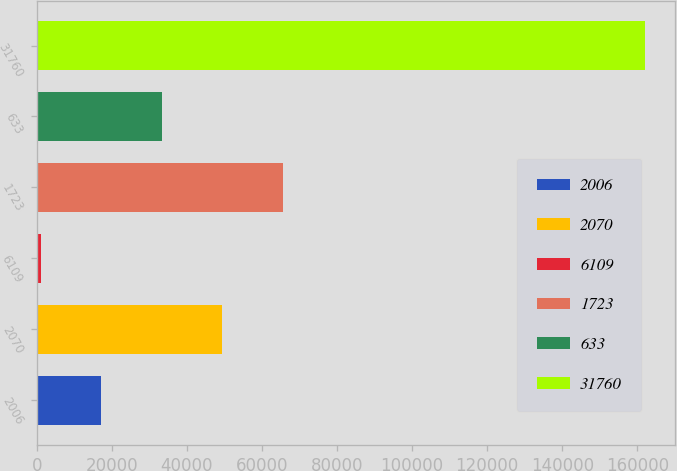<chart> <loc_0><loc_0><loc_500><loc_500><bar_chart><fcel>2006<fcel>2070<fcel>6109<fcel>1723<fcel>633<fcel>31760<nl><fcel>17224.5<fcel>49401.5<fcel>1136<fcel>65490<fcel>33313<fcel>162021<nl></chart> 